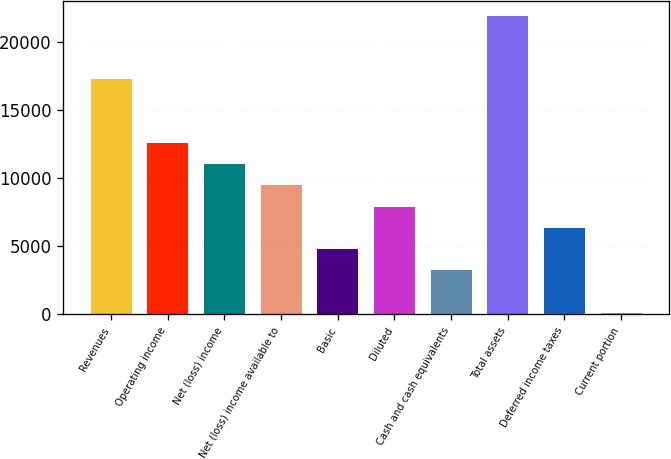Convert chart to OTSL. <chart><loc_0><loc_0><loc_500><loc_500><bar_chart><fcel>Revenues<fcel>Operating income<fcel>Net (loss) income<fcel>Net (loss) income available to<fcel>Basic<fcel>Diluted<fcel>Cash and cash equivalents<fcel>Total assets<fcel>Deferred income taxes<fcel>Current portion<nl><fcel>17231<fcel>12554<fcel>10995<fcel>9436<fcel>4759<fcel>7877<fcel>3200<fcel>21908<fcel>6318<fcel>82<nl></chart> 